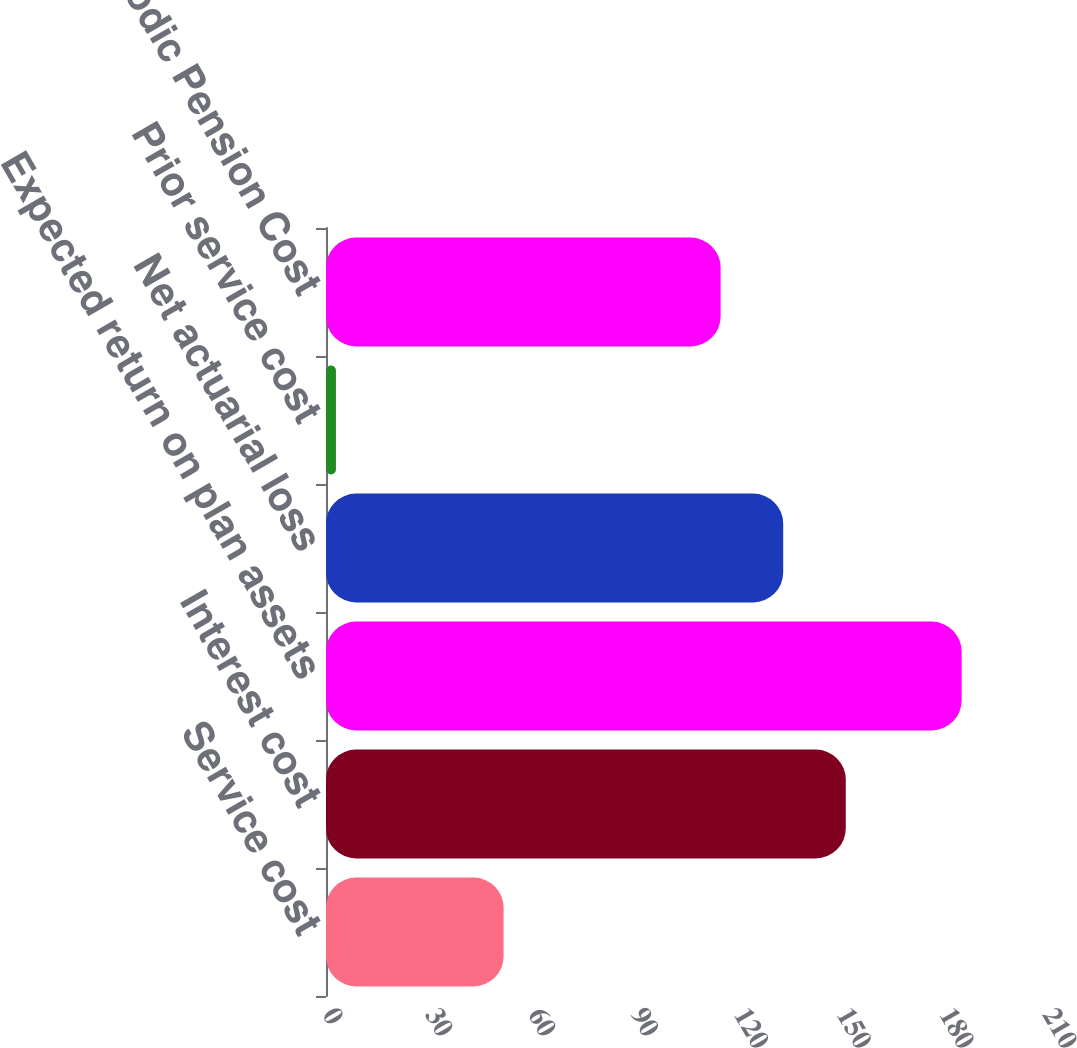Convert chart to OTSL. <chart><loc_0><loc_0><loc_500><loc_500><bar_chart><fcel>Service cost<fcel>Interest cost<fcel>Expected return on plan assets<fcel>Net actuarial loss<fcel>Prior service cost<fcel>Net Periodic Pension Cost<nl><fcel>51.8<fcel>151.6<fcel>185.4<fcel>133.35<fcel>2.9<fcel>115.1<nl></chart> 